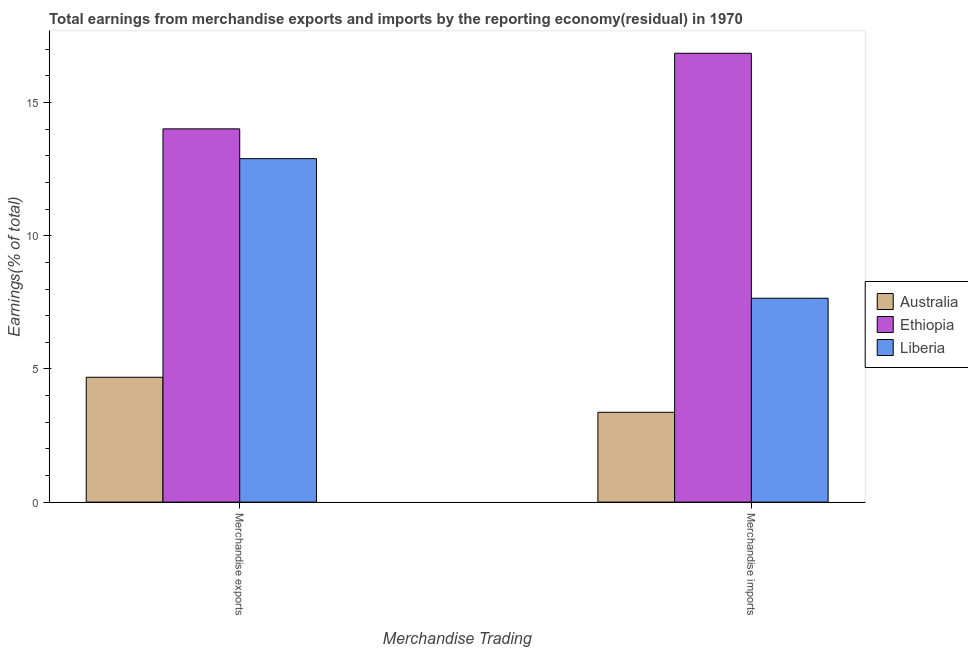How many bars are there on the 2nd tick from the right?
Make the answer very short. 3. What is the label of the 1st group of bars from the left?
Keep it short and to the point. Merchandise exports. What is the earnings from merchandise imports in Australia?
Offer a very short reply. 3.37. Across all countries, what is the maximum earnings from merchandise imports?
Provide a short and direct response. 16.85. Across all countries, what is the minimum earnings from merchandise imports?
Make the answer very short. 3.37. In which country was the earnings from merchandise imports maximum?
Make the answer very short. Ethiopia. What is the total earnings from merchandise imports in the graph?
Your answer should be very brief. 27.88. What is the difference between the earnings from merchandise imports in Ethiopia and that in Liberia?
Offer a terse response. 9.2. What is the difference between the earnings from merchandise imports in Australia and the earnings from merchandise exports in Liberia?
Your answer should be compact. -9.52. What is the average earnings from merchandise exports per country?
Your answer should be very brief. 10.53. What is the difference between the earnings from merchandise imports and earnings from merchandise exports in Ethiopia?
Provide a succinct answer. 2.84. In how many countries, is the earnings from merchandise exports greater than 16 %?
Your response must be concise. 0. What is the ratio of the earnings from merchandise imports in Ethiopia to that in Australia?
Make the answer very short. 5. Is the earnings from merchandise exports in Liberia less than that in Ethiopia?
Provide a short and direct response. Yes. What does the 2nd bar from the left in Merchandise exports represents?
Your answer should be very brief. Ethiopia. What does the 2nd bar from the right in Merchandise exports represents?
Ensure brevity in your answer.  Ethiopia. How many bars are there?
Your answer should be very brief. 6. How many countries are there in the graph?
Offer a very short reply. 3. Are the values on the major ticks of Y-axis written in scientific E-notation?
Make the answer very short. No. Does the graph contain any zero values?
Provide a short and direct response. No. Does the graph contain grids?
Ensure brevity in your answer.  No. Where does the legend appear in the graph?
Your response must be concise. Center right. What is the title of the graph?
Your answer should be very brief. Total earnings from merchandise exports and imports by the reporting economy(residual) in 1970. Does "Equatorial Guinea" appear as one of the legend labels in the graph?
Keep it short and to the point. No. What is the label or title of the X-axis?
Offer a terse response. Merchandise Trading. What is the label or title of the Y-axis?
Ensure brevity in your answer.  Earnings(% of total). What is the Earnings(% of total) in Australia in Merchandise exports?
Provide a short and direct response. 4.69. What is the Earnings(% of total) of Ethiopia in Merchandise exports?
Make the answer very short. 14.01. What is the Earnings(% of total) of Liberia in Merchandise exports?
Your response must be concise. 12.89. What is the Earnings(% of total) of Australia in Merchandise imports?
Your response must be concise. 3.37. What is the Earnings(% of total) in Ethiopia in Merchandise imports?
Your answer should be compact. 16.85. What is the Earnings(% of total) in Liberia in Merchandise imports?
Provide a succinct answer. 7.65. Across all Merchandise Trading, what is the maximum Earnings(% of total) in Australia?
Make the answer very short. 4.69. Across all Merchandise Trading, what is the maximum Earnings(% of total) in Ethiopia?
Give a very brief answer. 16.85. Across all Merchandise Trading, what is the maximum Earnings(% of total) of Liberia?
Make the answer very short. 12.89. Across all Merchandise Trading, what is the minimum Earnings(% of total) of Australia?
Your response must be concise. 3.37. Across all Merchandise Trading, what is the minimum Earnings(% of total) in Ethiopia?
Provide a succinct answer. 14.01. Across all Merchandise Trading, what is the minimum Earnings(% of total) of Liberia?
Offer a terse response. 7.65. What is the total Earnings(% of total) in Australia in the graph?
Ensure brevity in your answer.  8.06. What is the total Earnings(% of total) in Ethiopia in the graph?
Provide a succinct answer. 30.86. What is the total Earnings(% of total) of Liberia in the graph?
Your answer should be compact. 20.55. What is the difference between the Earnings(% of total) in Australia in Merchandise exports and that in Merchandise imports?
Keep it short and to the point. 1.31. What is the difference between the Earnings(% of total) of Ethiopia in Merchandise exports and that in Merchandise imports?
Keep it short and to the point. -2.84. What is the difference between the Earnings(% of total) in Liberia in Merchandise exports and that in Merchandise imports?
Ensure brevity in your answer.  5.24. What is the difference between the Earnings(% of total) of Australia in Merchandise exports and the Earnings(% of total) of Ethiopia in Merchandise imports?
Provide a succinct answer. -12.16. What is the difference between the Earnings(% of total) in Australia in Merchandise exports and the Earnings(% of total) in Liberia in Merchandise imports?
Make the answer very short. -2.97. What is the difference between the Earnings(% of total) of Ethiopia in Merchandise exports and the Earnings(% of total) of Liberia in Merchandise imports?
Your answer should be compact. 6.36. What is the average Earnings(% of total) of Australia per Merchandise Trading?
Offer a terse response. 4.03. What is the average Earnings(% of total) in Ethiopia per Merchandise Trading?
Your answer should be very brief. 15.43. What is the average Earnings(% of total) in Liberia per Merchandise Trading?
Offer a very short reply. 10.27. What is the difference between the Earnings(% of total) of Australia and Earnings(% of total) of Ethiopia in Merchandise exports?
Provide a succinct answer. -9.32. What is the difference between the Earnings(% of total) in Australia and Earnings(% of total) in Liberia in Merchandise exports?
Your answer should be compact. -8.21. What is the difference between the Earnings(% of total) of Ethiopia and Earnings(% of total) of Liberia in Merchandise exports?
Give a very brief answer. 1.12. What is the difference between the Earnings(% of total) in Australia and Earnings(% of total) in Ethiopia in Merchandise imports?
Your response must be concise. -13.48. What is the difference between the Earnings(% of total) in Australia and Earnings(% of total) in Liberia in Merchandise imports?
Give a very brief answer. -4.28. What is the difference between the Earnings(% of total) in Ethiopia and Earnings(% of total) in Liberia in Merchandise imports?
Make the answer very short. 9.2. What is the ratio of the Earnings(% of total) in Australia in Merchandise exports to that in Merchandise imports?
Offer a terse response. 1.39. What is the ratio of the Earnings(% of total) in Ethiopia in Merchandise exports to that in Merchandise imports?
Your answer should be compact. 0.83. What is the ratio of the Earnings(% of total) of Liberia in Merchandise exports to that in Merchandise imports?
Offer a very short reply. 1.68. What is the difference between the highest and the second highest Earnings(% of total) in Australia?
Provide a succinct answer. 1.31. What is the difference between the highest and the second highest Earnings(% of total) in Ethiopia?
Give a very brief answer. 2.84. What is the difference between the highest and the second highest Earnings(% of total) of Liberia?
Your response must be concise. 5.24. What is the difference between the highest and the lowest Earnings(% of total) in Australia?
Keep it short and to the point. 1.31. What is the difference between the highest and the lowest Earnings(% of total) of Ethiopia?
Ensure brevity in your answer.  2.84. What is the difference between the highest and the lowest Earnings(% of total) in Liberia?
Offer a very short reply. 5.24. 